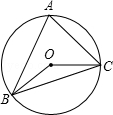What kind of symmetry does the figure demonstrate? The image you're observing showcases a fascinating instance of radial symmetry, centered around point O which is the circle's center. This geometric figure, with triangle ABC inscribed within the circle, maintains its symmetry because any rotation around point O or reflection across a diameter passing through O would maintain the figure's congruence with its original position. 